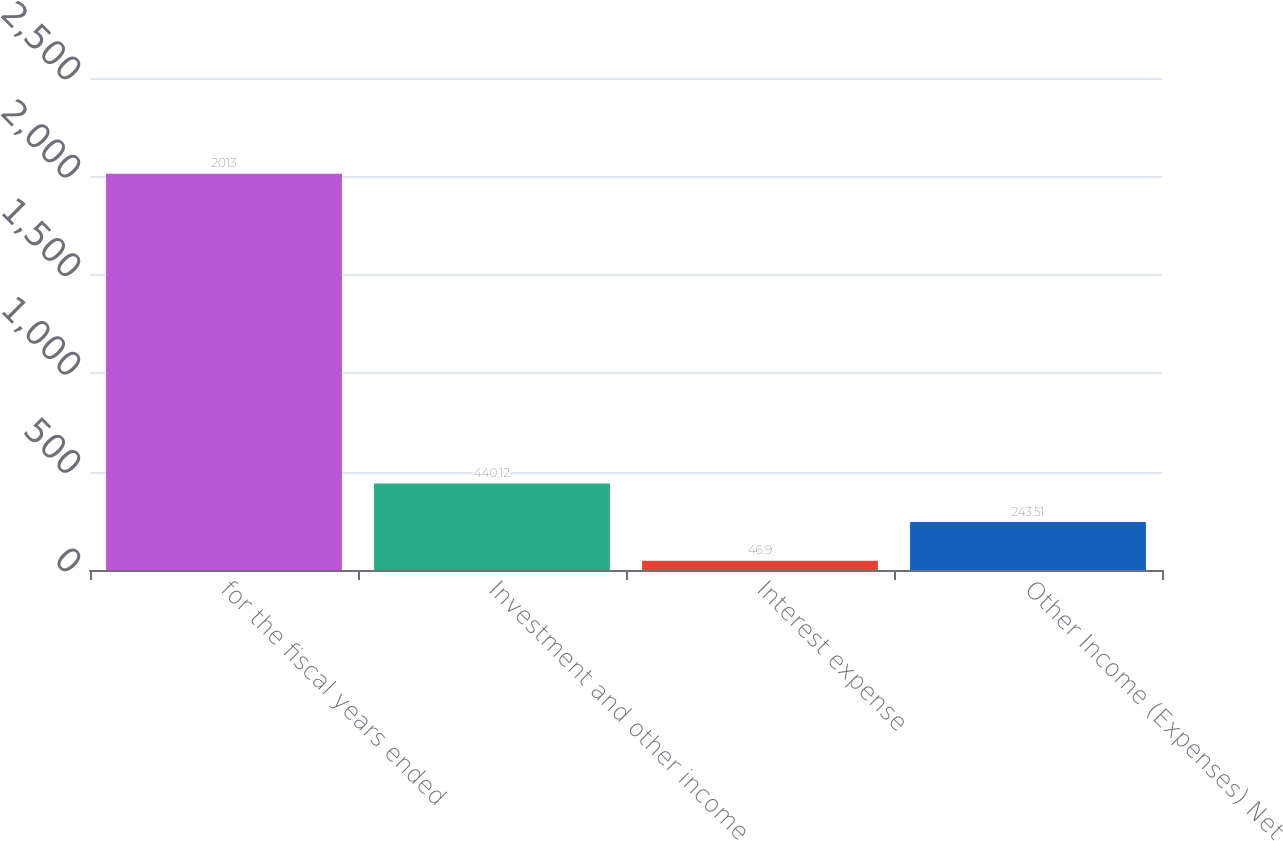Convert chart. <chart><loc_0><loc_0><loc_500><loc_500><bar_chart><fcel>for the fiscal years ended<fcel>Investment and other income<fcel>Interest expense<fcel>Other Income (Expenses) Net<nl><fcel>2013<fcel>440.12<fcel>46.9<fcel>243.51<nl></chart> 